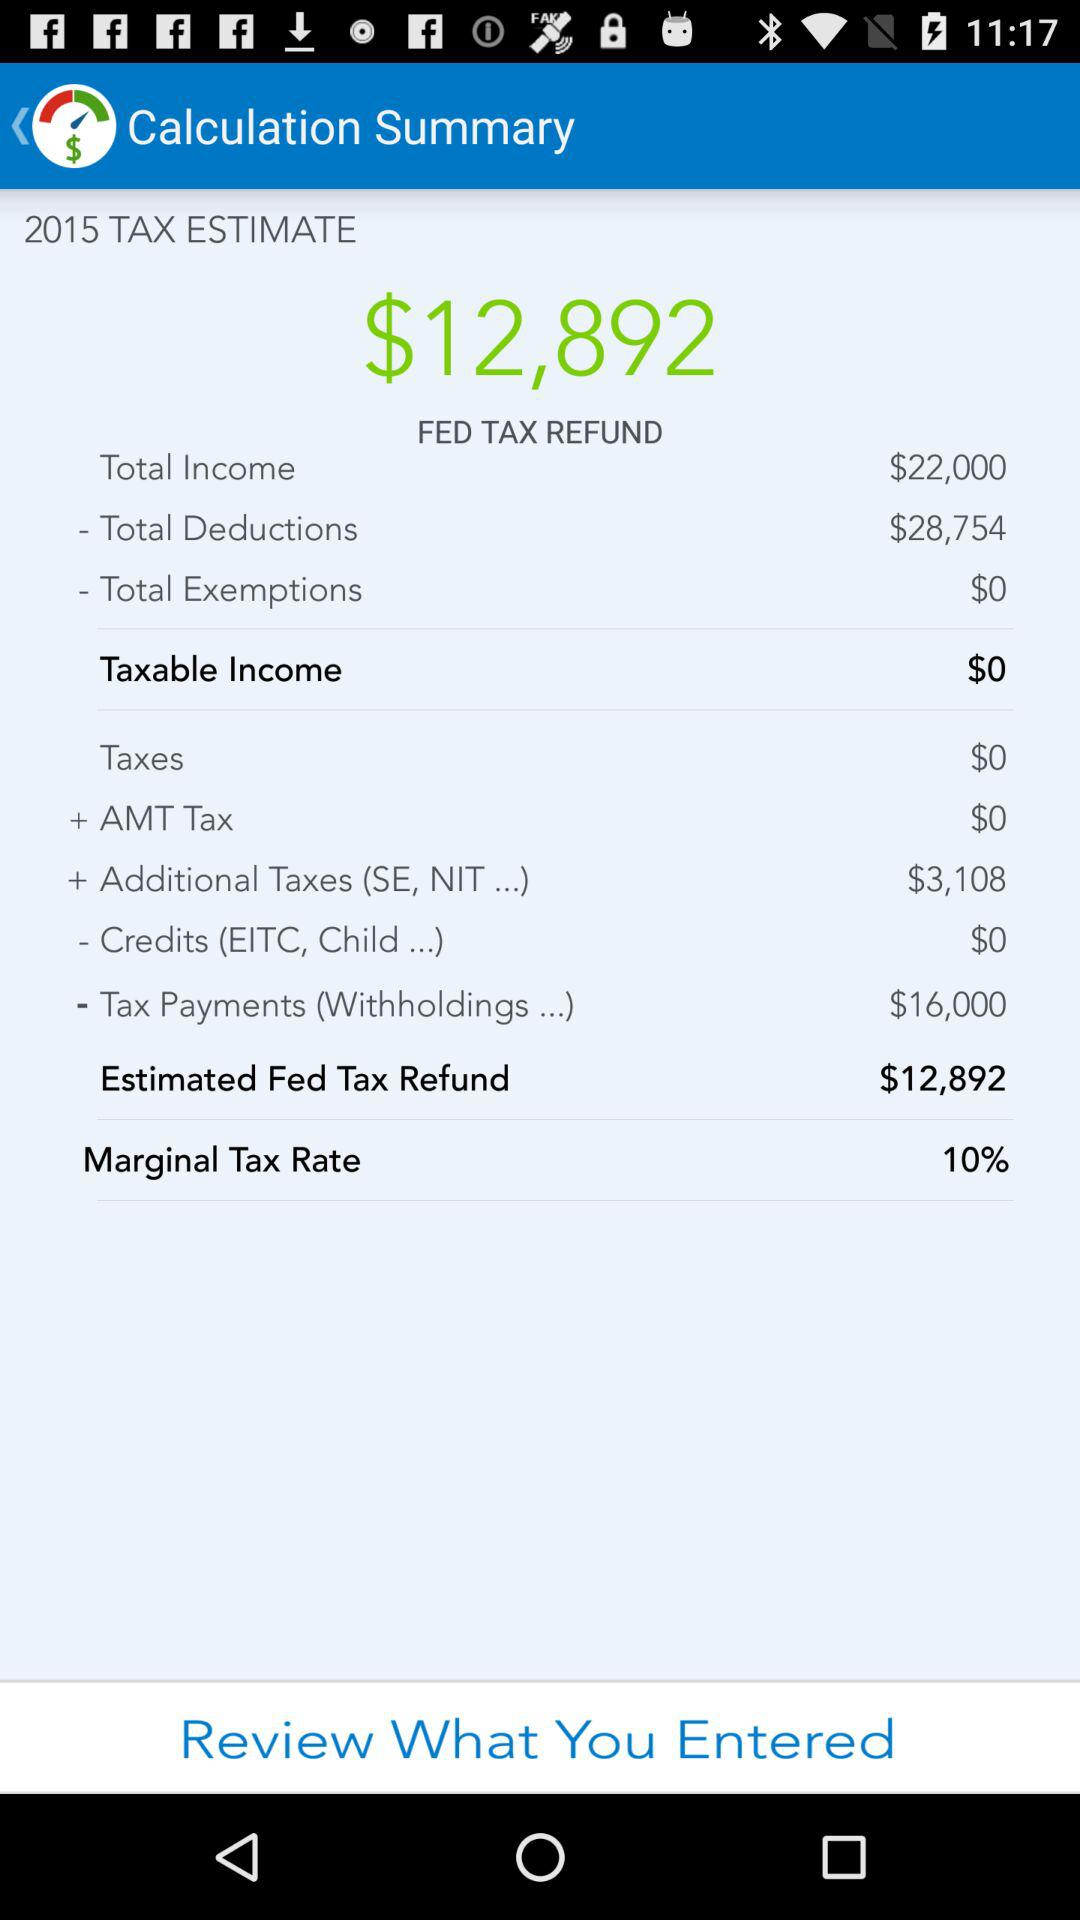What year tax estimate is this? The year is 2015. 